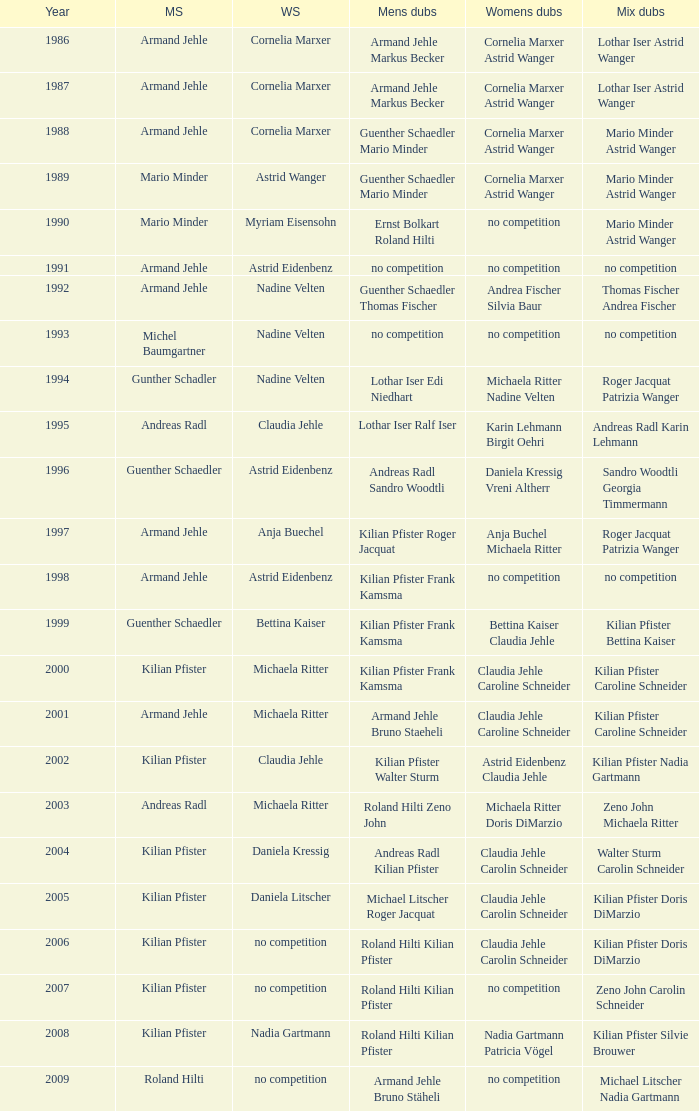In 1987 who was the mens singles Armand Jehle. 